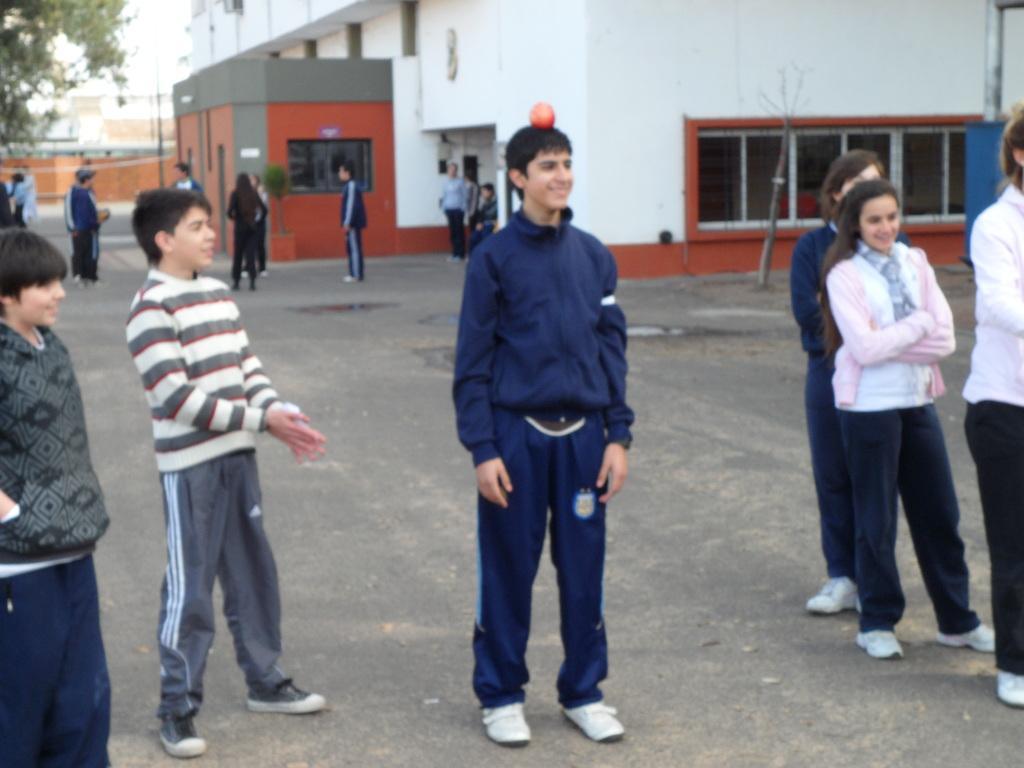Could you give a brief overview of what you see in this image? In this image, we can see few people on the floor. Background we can see a building with walls and windows. In the top left corner, there is a tree. Right side of the image, we can see a pole. Here we can see few people are smiling. Here a red color object is placed on a human head. 